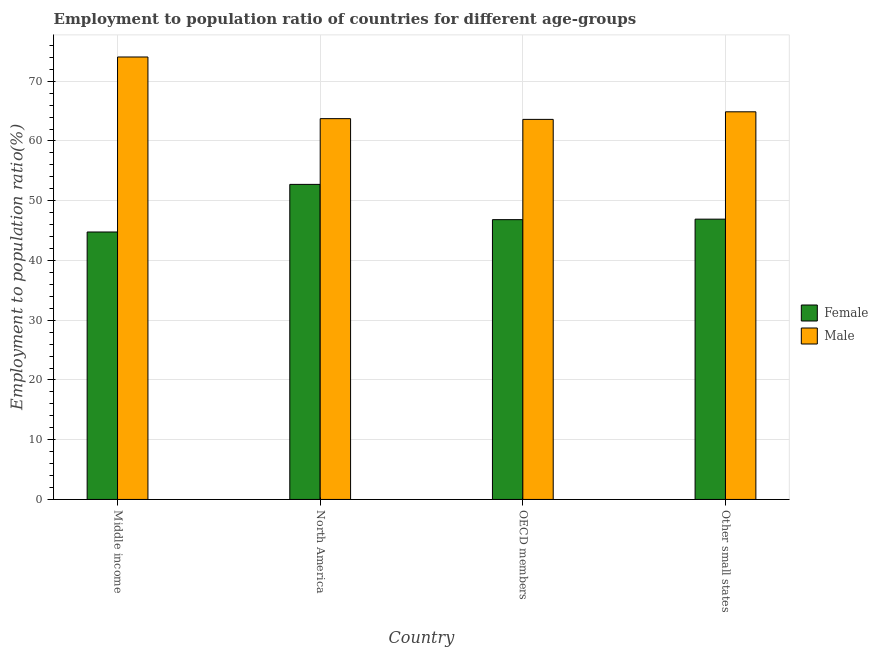How many different coloured bars are there?
Ensure brevity in your answer.  2. How many groups of bars are there?
Your response must be concise. 4. How many bars are there on the 3rd tick from the left?
Offer a very short reply. 2. What is the label of the 4th group of bars from the left?
Offer a very short reply. Other small states. In how many cases, is the number of bars for a given country not equal to the number of legend labels?
Provide a short and direct response. 0. What is the employment to population ratio(female) in North America?
Your answer should be very brief. 52.73. Across all countries, what is the maximum employment to population ratio(male)?
Ensure brevity in your answer.  74.06. Across all countries, what is the minimum employment to population ratio(female)?
Provide a succinct answer. 44.77. In which country was the employment to population ratio(female) minimum?
Keep it short and to the point. Middle income. What is the total employment to population ratio(female) in the graph?
Your answer should be compact. 191.25. What is the difference between the employment to population ratio(female) in North America and that in Other small states?
Keep it short and to the point. 5.82. What is the difference between the employment to population ratio(male) in OECD members and the employment to population ratio(female) in Other small states?
Provide a short and direct response. 16.7. What is the average employment to population ratio(female) per country?
Ensure brevity in your answer.  47.81. What is the difference between the employment to population ratio(female) and employment to population ratio(male) in OECD members?
Offer a terse response. -16.78. In how many countries, is the employment to population ratio(female) greater than 24 %?
Provide a succinct answer. 4. What is the ratio of the employment to population ratio(male) in Middle income to that in OECD members?
Your answer should be very brief. 1.16. Is the employment to population ratio(female) in Middle income less than that in OECD members?
Your response must be concise. Yes. Is the difference between the employment to population ratio(female) in OECD members and Other small states greater than the difference between the employment to population ratio(male) in OECD members and Other small states?
Offer a very short reply. Yes. What is the difference between the highest and the second highest employment to population ratio(female)?
Provide a succinct answer. 5.82. What is the difference between the highest and the lowest employment to population ratio(female)?
Offer a terse response. 7.97. How many bars are there?
Your response must be concise. 8. Are all the bars in the graph horizontal?
Make the answer very short. No. How many countries are there in the graph?
Your answer should be compact. 4. What is the difference between two consecutive major ticks on the Y-axis?
Your answer should be very brief. 10. Are the values on the major ticks of Y-axis written in scientific E-notation?
Keep it short and to the point. No. What is the title of the graph?
Offer a very short reply. Employment to population ratio of countries for different age-groups. What is the label or title of the X-axis?
Your answer should be compact. Country. What is the Employment to population ratio(%) of Female in Middle income?
Ensure brevity in your answer.  44.77. What is the Employment to population ratio(%) in Male in Middle income?
Your response must be concise. 74.06. What is the Employment to population ratio(%) in Female in North America?
Provide a short and direct response. 52.73. What is the Employment to population ratio(%) of Male in North America?
Offer a very short reply. 63.74. What is the Employment to population ratio(%) in Female in OECD members?
Keep it short and to the point. 46.83. What is the Employment to population ratio(%) in Male in OECD members?
Make the answer very short. 63.61. What is the Employment to population ratio(%) of Female in Other small states?
Ensure brevity in your answer.  46.91. What is the Employment to population ratio(%) in Male in Other small states?
Your response must be concise. 64.88. Across all countries, what is the maximum Employment to population ratio(%) in Female?
Give a very brief answer. 52.73. Across all countries, what is the maximum Employment to population ratio(%) of Male?
Keep it short and to the point. 74.06. Across all countries, what is the minimum Employment to population ratio(%) in Female?
Make the answer very short. 44.77. Across all countries, what is the minimum Employment to population ratio(%) in Male?
Keep it short and to the point. 63.61. What is the total Employment to population ratio(%) in Female in the graph?
Your answer should be very brief. 191.25. What is the total Employment to population ratio(%) of Male in the graph?
Give a very brief answer. 266.29. What is the difference between the Employment to population ratio(%) of Female in Middle income and that in North America?
Provide a succinct answer. -7.97. What is the difference between the Employment to population ratio(%) of Male in Middle income and that in North America?
Your answer should be compact. 10.32. What is the difference between the Employment to population ratio(%) of Female in Middle income and that in OECD members?
Give a very brief answer. -2.06. What is the difference between the Employment to population ratio(%) of Male in Middle income and that in OECD members?
Offer a very short reply. 10.44. What is the difference between the Employment to population ratio(%) in Female in Middle income and that in Other small states?
Give a very brief answer. -2.15. What is the difference between the Employment to population ratio(%) in Male in Middle income and that in Other small states?
Make the answer very short. 9.17. What is the difference between the Employment to population ratio(%) in Female in North America and that in OECD members?
Give a very brief answer. 5.9. What is the difference between the Employment to population ratio(%) of Male in North America and that in OECD members?
Offer a very short reply. 0.12. What is the difference between the Employment to population ratio(%) of Female in North America and that in Other small states?
Provide a short and direct response. 5.82. What is the difference between the Employment to population ratio(%) of Male in North America and that in Other small states?
Offer a terse response. -1.14. What is the difference between the Employment to population ratio(%) in Female in OECD members and that in Other small states?
Keep it short and to the point. -0.08. What is the difference between the Employment to population ratio(%) of Male in OECD members and that in Other small states?
Ensure brevity in your answer.  -1.27. What is the difference between the Employment to population ratio(%) in Female in Middle income and the Employment to population ratio(%) in Male in North America?
Make the answer very short. -18.97. What is the difference between the Employment to population ratio(%) of Female in Middle income and the Employment to population ratio(%) of Male in OECD members?
Offer a terse response. -18.85. What is the difference between the Employment to population ratio(%) of Female in Middle income and the Employment to population ratio(%) of Male in Other small states?
Your answer should be compact. -20.12. What is the difference between the Employment to population ratio(%) in Female in North America and the Employment to population ratio(%) in Male in OECD members?
Your answer should be compact. -10.88. What is the difference between the Employment to population ratio(%) in Female in North America and the Employment to population ratio(%) in Male in Other small states?
Give a very brief answer. -12.15. What is the difference between the Employment to population ratio(%) in Female in OECD members and the Employment to population ratio(%) in Male in Other small states?
Ensure brevity in your answer.  -18.05. What is the average Employment to population ratio(%) of Female per country?
Ensure brevity in your answer.  47.81. What is the average Employment to population ratio(%) of Male per country?
Provide a succinct answer. 66.57. What is the difference between the Employment to population ratio(%) of Female and Employment to population ratio(%) of Male in Middle income?
Your response must be concise. -29.29. What is the difference between the Employment to population ratio(%) of Female and Employment to population ratio(%) of Male in North America?
Your response must be concise. -11. What is the difference between the Employment to population ratio(%) of Female and Employment to population ratio(%) of Male in OECD members?
Your answer should be very brief. -16.78. What is the difference between the Employment to population ratio(%) of Female and Employment to population ratio(%) of Male in Other small states?
Your response must be concise. -17.97. What is the ratio of the Employment to population ratio(%) in Female in Middle income to that in North America?
Your answer should be compact. 0.85. What is the ratio of the Employment to population ratio(%) in Male in Middle income to that in North America?
Keep it short and to the point. 1.16. What is the ratio of the Employment to population ratio(%) of Female in Middle income to that in OECD members?
Make the answer very short. 0.96. What is the ratio of the Employment to population ratio(%) of Male in Middle income to that in OECD members?
Your answer should be very brief. 1.16. What is the ratio of the Employment to population ratio(%) of Female in Middle income to that in Other small states?
Make the answer very short. 0.95. What is the ratio of the Employment to population ratio(%) of Male in Middle income to that in Other small states?
Provide a succinct answer. 1.14. What is the ratio of the Employment to population ratio(%) of Female in North America to that in OECD members?
Make the answer very short. 1.13. What is the ratio of the Employment to population ratio(%) in Male in North America to that in OECD members?
Make the answer very short. 1. What is the ratio of the Employment to population ratio(%) in Female in North America to that in Other small states?
Offer a terse response. 1.12. What is the ratio of the Employment to population ratio(%) in Male in North America to that in Other small states?
Make the answer very short. 0.98. What is the ratio of the Employment to population ratio(%) of Female in OECD members to that in Other small states?
Your answer should be very brief. 1. What is the ratio of the Employment to population ratio(%) in Male in OECD members to that in Other small states?
Give a very brief answer. 0.98. What is the difference between the highest and the second highest Employment to population ratio(%) in Female?
Your response must be concise. 5.82. What is the difference between the highest and the second highest Employment to population ratio(%) of Male?
Give a very brief answer. 9.17. What is the difference between the highest and the lowest Employment to population ratio(%) in Female?
Give a very brief answer. 7.97. What is the difference between the highest and the lowest Employment to population ratio(%) of Male?
Give a very brief answer. 10.44. 